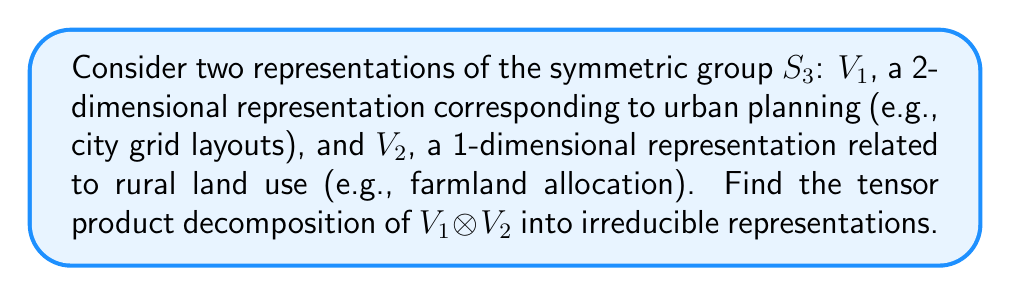Provide a solution to this math problem. 1) First, recall the irreducible representations of $S_3$:
   - The trivial representation: $\mathbf{1}$ (1-dimensional)
   - The sign representation: $\varepsilon$ (1-dimensional)
   - The standard representation: $V$ (2-dimensional)

2) The character table of $S_3$ is:
   $$
   \begin{array}{c|ccc}
   & (1) & (12) & (123) \\
   \hline
   \mathbf{1} & 1 & 1 & 1 \\
   \varepsilon & 1 & -1 & 1 \\
   V & 2 & 0 & -1
   \end{array}
   $$

3) Given information:
   - $V_1$ is 2-dimensional (likely the standard representation $V$)
   - $V_2$ is 1-dimensional (either $\mathbf{1}$ or $\varepsilon$)

4) Let's assume $V_1 = V$ and $V_2 = \mathbf{1}$ (as urban planning often involves symmetry)

5) To find $V_1 \otimes V_2$, we multiply their characters:
   $$
   \chi_{V_1 \otimes V_2} = \chi_V \cdot \chi_{\mathbf{1}} = (2,0,-1) \cdot (1,1,1) = (2,0,-1)
   $$

6) This character matches the standard representation $V$

Therefore, $V_1 \otimes V_2 \cong V$
Answer: $V_1 \otimes V_2 \cong V$ 